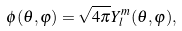Convert formula to latex. <formula><loc_0><loc_0><loc_500><loc_500>\phi ( \theta , \varphi ) = \sqrt { 4 \pi } Y _ { l } ^ { m } ( \theta , \varphi ) ,</formula> 